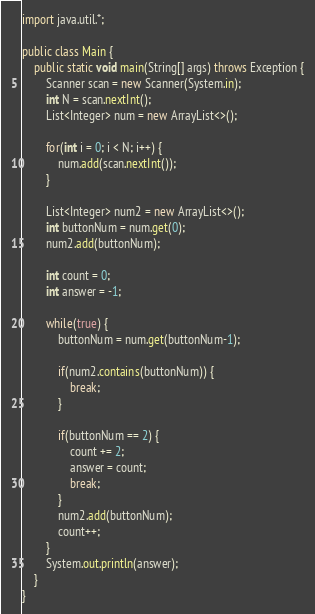<code> <loc_0><loc_0><loc_500><loc_500><_Java_>import java.util.*;

public class Main {
    public static void main(String[] args) throws Exception {
        Scanner scan = new Scanner(System.in);
        int N = scan.nextInt();
        List<Integer> num = new ArrayList<>();
        
        for(int i = 0; i < N; i++) {
            num.add(scan.nextInt());
        }
        
        List<Integer> num2 = new ArrayList<>();
        int buttonNum = num.get(0);
        num2.add(buttonNum);

        int count = 0;
        int answer = -1;
        
        while(true) {
            buttonNum = num.get(buttonNum-1);
            
            if(num2.contains(buttonNum)) {
                break; 
            }
            
            if(buttonNum == 2) {
                count += 2;
                answer = count;
                break;
            }
            num2.add(buttonNum);
            count++;
        }
        System.out.println(answer);
    }
}
</code> 